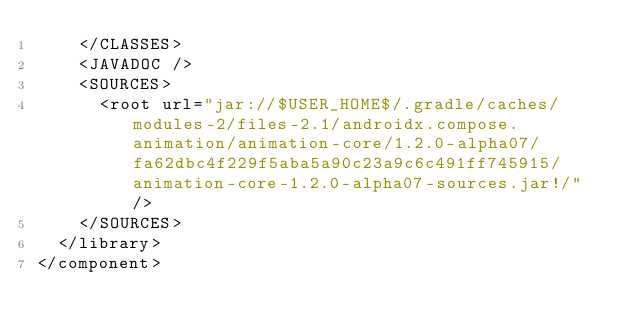<code> <loc_0><loc_0><loc_500><loc_500><_XML_>    </CLASSES>
    <JAVADOC />
    <SOURCES>
      <root url="jar://$USER_HOME$/.gradle/caches/modules-2/files-2.1/androidx.compose.animation/animation-core/1.2.0-alpha07/fa62dbc4f229f5aba5a90c23a9c6c491ff745915/animation-core-1.2.0-alpha07-sources.jar!/" />
    </SOURCES>
  </library>
</component></code> 